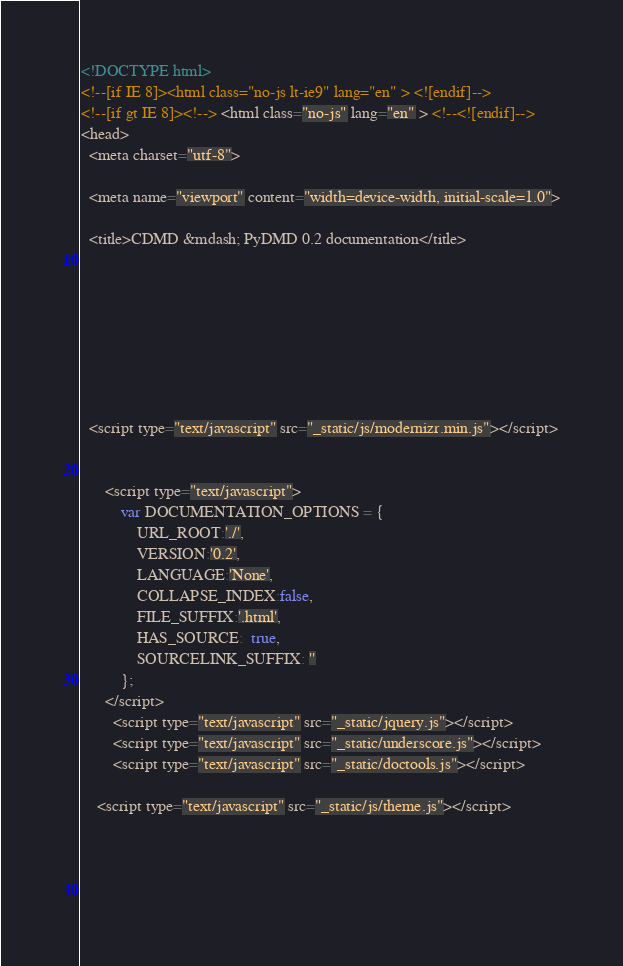<code> <loc_0><loc_0><loc_500><loc_500><_HTML_>

<!DOCTYPE html>
<!--[if IE 8]><html class="no-js lt-ie9" lang="en" > <![endif]-->
<!--[if gt IE 8]><!--> <html class="no-js" lang="en" > <!--<![endif]-->
<head>
  <meta charset="utf-8">
  
  <meta name="viewport" content="width=device-width, initial-scale=1.0">
  
  <title>CDMD &mdash; PyDMD 0.2 documentation</title>
  

  
  
  
  

  
  <script type="text/javascript" src="_static/js/modernizr.min.js"></script>
  
    
      <script type="text/javascript">
          var DOCUMENTATION_OPTIONS = {
              URL_ROOT:'./',
              VERSION:'0.2',
              LANGUAGE:'None',
              COLLAPSE_INDEX:false,
              FILE_SUFFIX:'.html',
              HAS_SOURCE:  true,
              SOURCELINK_SUFFIX: ''
          };
      </script>
        <script type="text/javascript" src="_static/jquery.js"></script>
        <script type="text/javascript" src="_static/underscore.js"></script>
        <script type="text/javascript" src="_static/doctools.js"></script>
    
    <script type="text/javascript" src="_static/js/theme.js"></script>

    

  </code> 